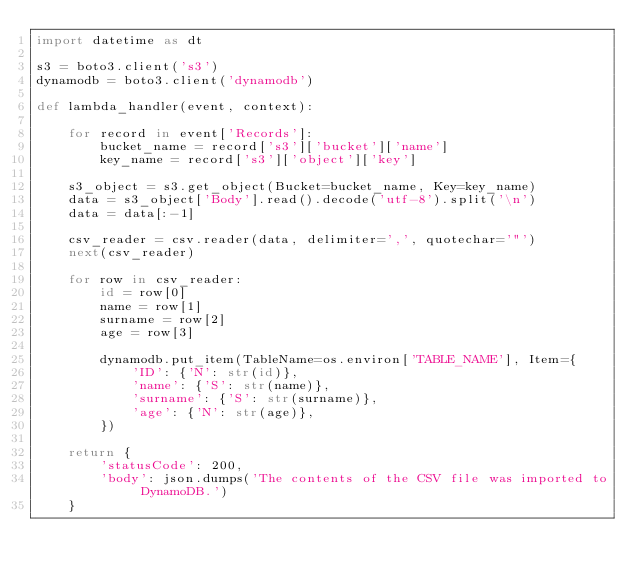Convert code to text. <code><loc_0><loc_0><loc_500><loc_500><_Python_>import datetime as dt

s3 = boto3.client('s3')
dynamodb = boto3.client('dynamodb')

def lambda_handler(event, context):
    
    for record in event['Records']:
        bucket_name = record['s3']['bucket']['name']
        key_name = record['s3']['object']['key']
        
    s3_object = s3.get_object(Bucket=bucket_name, Key=key_name)
    data = s3_object['Body'].read().decode('utf-8').split('\n')
    data = data[:-1]
    
    csv_reader = csv.reader(data, delimiter=',', quotechar='"')
    next(csv_reader)
    
    for row in csv_reader:
        id = row[0]
        name = row[1]
        surname = row[2]
        age = row[3]
        
        dynamodb.put_item(TableName=os.environ['TABLE_NAME'], Item={
            'ID': {'N': str(id)},
            'name': {'S': str(name)},
            'surname': {'S': str(surname)},
            'age': {'N': str(age)},
        })

    return {
        'statusCode': 200,
        'body': json.dumps('The contents of the CSV file was imported to DynamoDB.')
    }
</code> 